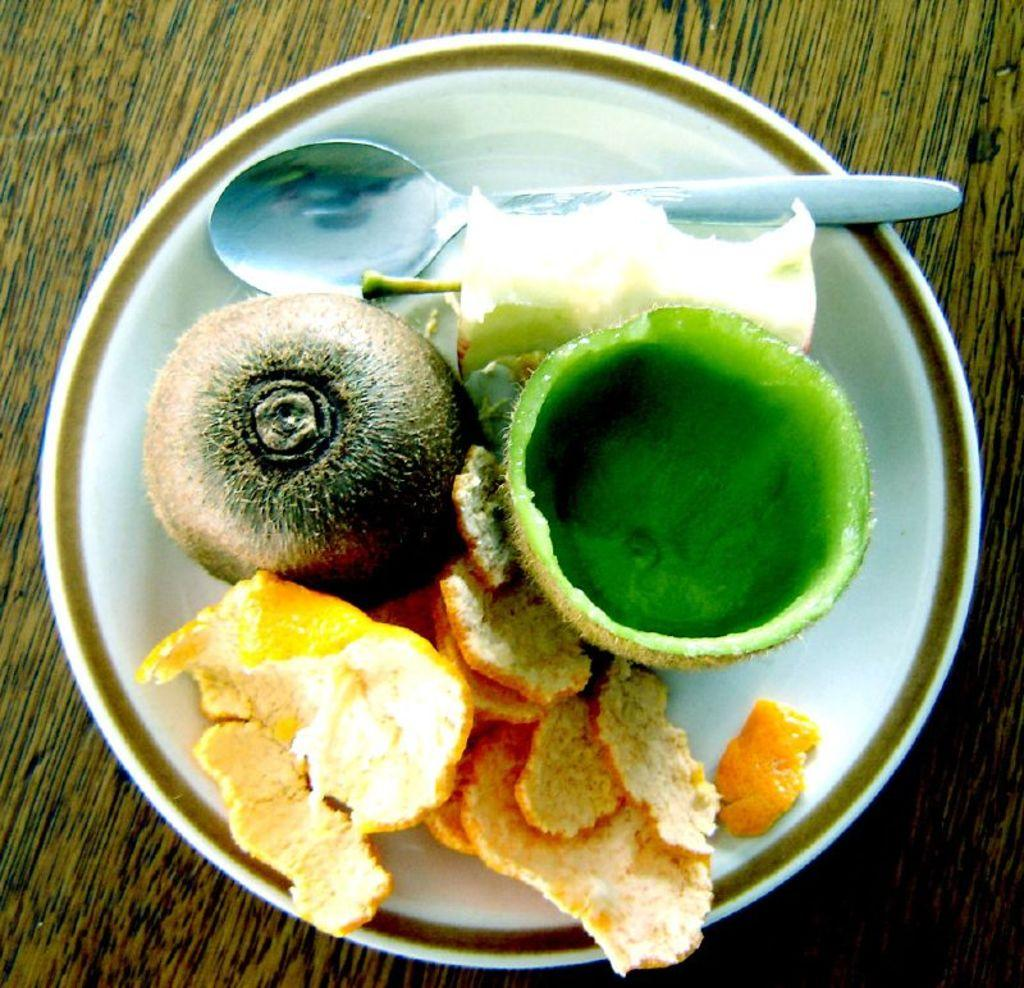What is in the bowl that is visible in the image? There is a bowl filled with fruits in the image. What type of fruits can be seen in the bowl? The specific types of fruits in the bowl cannot be determined from the image. What might be used for serving or eating the fruits in the image? The image does not show any utensils or serving dishes, so it cannot be determined from the image. What type of wilderness can be seen in the background of the image? There is no wilderness visible in the image; it only shows a bowl filled with fruits. 